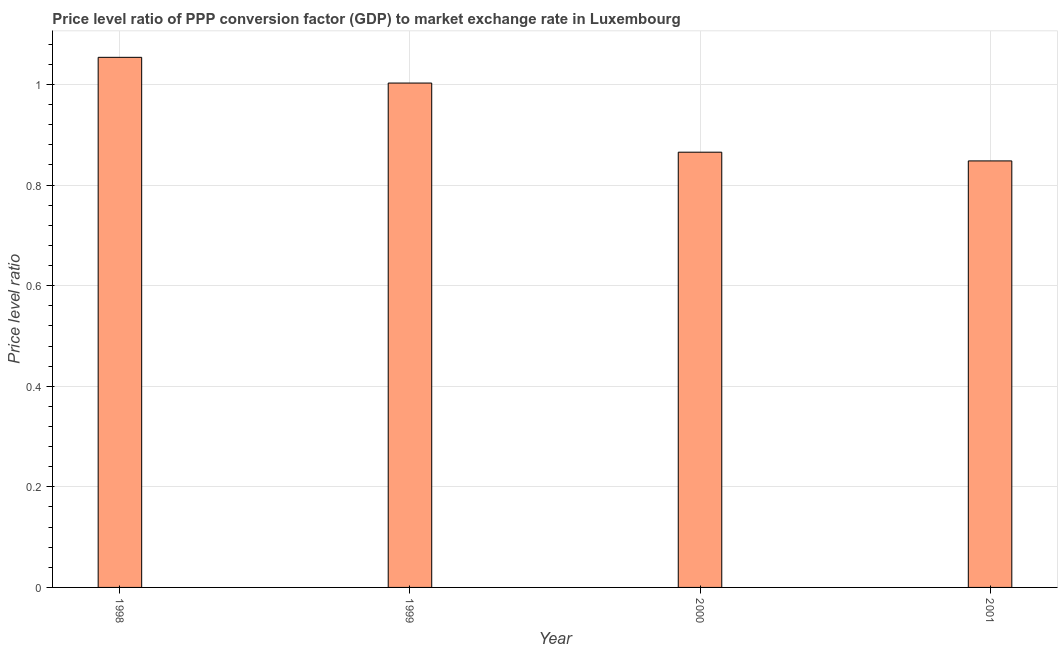Does the graph contain grids?
Provide a short and direct response. Yes. What is the title of the graph?
Keep it short and to the point. Price level ratio of PPP conversion factor (GDP) to market exchange rate in Luxembourg. What is the label or title of the X-axis?
Your answer should be very brief. Year. What is the label or title of the Y-axis?
Ensure brevity in your answer.  Price level ratio. What is the price level ratio in 1998?
Offer a terse response. 1.05. Across all years, what is the maximum price level ratio?
Your answer should be very brief. 1.05. Across all years, what is the minimum price level ratio?
Your answer should be very brief. 0.85. In which year was the price level ratio maximum?
Keep it short and to the point. 1998. What is the sum of the price level ratio?
Make the answer very short. 3.77. What is the difference between the price level ratio in 1998 and 2000?
Keep it short and to the point. 0.19. What is the average price level ratio per year?
Offer a very short reply. 0.94. What is the median price level ratio?
Offer a terse response. 0.93. In how many years, is the price level ratio greater than 0.24 ?
Your answer should be compact. 4. What is the ratio of the price level ratio in 1998 to that in 2000?
Ensure brevity in your answer.  1.22. Is the price level ratio in 1998 less than that in 2001?
Make the answer very short. No. What is the difference between the highest and the second highest price level ratio?
Your answer should be compact. 0.05. What is the difference between the highest and the lowest price level ratio?
Your answer should be compact. 0.21. In how many years, is the price level ratio greater than the average price level ratio taken over all years?
Offer a very short reply. 2. How many bars are there?
Your answer should be compact. 4. Are all the bars in the graph horizontal?
Your response must be concise. No. How many years are there in the graph?
Ensure brevity in your answer.  4. What is the Price level ratio of 1998?
Provide a succinct answer. 1.05. What is the Price level ratio in 1999?
Give a very brief answer. 1. What is the Price level ratio in 2000?
Your answer should be compact. 0.87. What is the Price level ratio of 2001?
Your answer should be very brief. 0.85. What is the difference between the Price level ratio in 1998 and 1999?
Ensure brevity in your answer.  0.05. What is the difference between the Price level ratio in 1998 and 2000?
Your response must be concise. 0.19. What is the difference between the Price level ratio in 1998 and 2001?
Give a very brief answer. 0.21. What is the difference between the Price level ratio in 1999 and 2000?
Keep it short and to the point. 0.14. What is the difference between the Price level ratio in 1999 and 2001?
Make the answer very short. 0.15. What is the difference between the Price level ratio in 2000 and 2001?
Ensure brevity in your answer.  0.02. What is the ratio of the Price level ratio in 1998 to that in 1999?
Give a very brief answer. 1.05. What is the ratio of the Price level ratio in 1998 to that in 2000?
Make the answer very short. 1.22. What is the ratio of the Price level ratio in 1998 to that in 2001?
Provide a succinct answer. 1.24. What is the ratio of the Price level ratio in 1999 to that in 2000?
Offer a terse response. 1.16. What is the ratio of the Price level ratio in 1999 to that in 2001?
Provide a succinct answer. 1.18. What is the ratio of the Price level ratio in 2000 to that in 2001?
Provide a short and direct response. 1.02. 